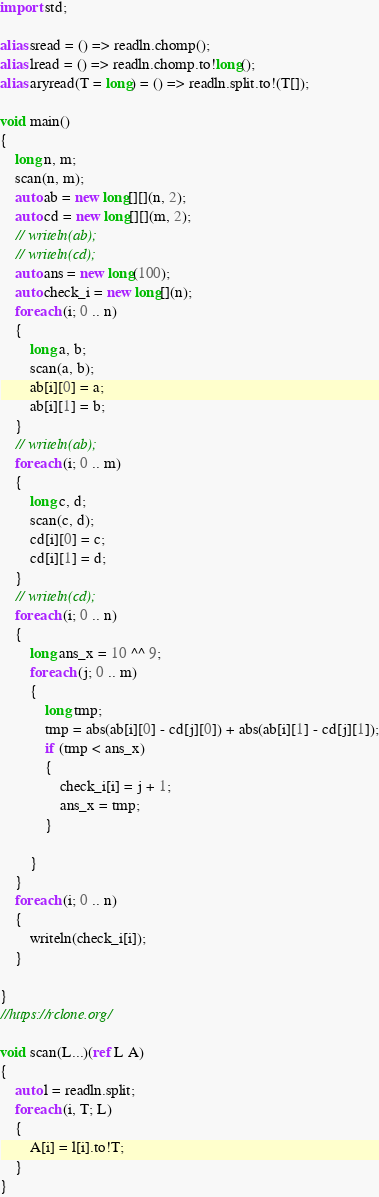Convert code to text. <code><loc_0><loc_0><loc_500><loc_500><_D_>import std;

alias sread = () => readln.chomp();
alias lread = () => readln.chomp.to!long();
alias aryread(T = long) = () => readln.split.to!(T[]);

void main()
{
    long n, m;
    scan(n, m);
    auto ab = new long[][](n, 2);
    auto cd = new long[][](m, 2);
    // writeln(ab);
    // writeln(cd);
    auto ans = new long(100);
    auto check_i = new long[](n);
    foreach (i; 0 .. n)
    {
        long a, b;
        scan(a, b);
        ab[i][0] = a;
        ab[i][1] = b;
    }
    // writeln(ab);
    foreach (i; 0 .. m)
    {
        long c, d;
        scan(c, d);
        cd[i][0] = c;
        cd[i][1] = d;
    }
    // writeln(cd);
    foreach (i; 0 .. n)
    {
        long ans_x = 10 ^^ 9;
        foreach (j; 0 .. m)
        {
            long tmp;
            tmp = abs(ab[i][0] - cd[j][0]) + abs(ab[i][1] - cd[j][1]);
            if (tmp < ans_x)
            {
                check_i[i] = j + 1;
                ans_x = tmp;
            }

        }
    }
    foreach (i; 0 .. n)
    {
        writeln(check_i[i]);
    }

}
//https://rclone.org/

void scan(L...)(ref L A)
{
    auto l = readln.split;
    foreach (i, T; L)
    {
        A[i] = l[i].to!T;
    }
}
</code> 